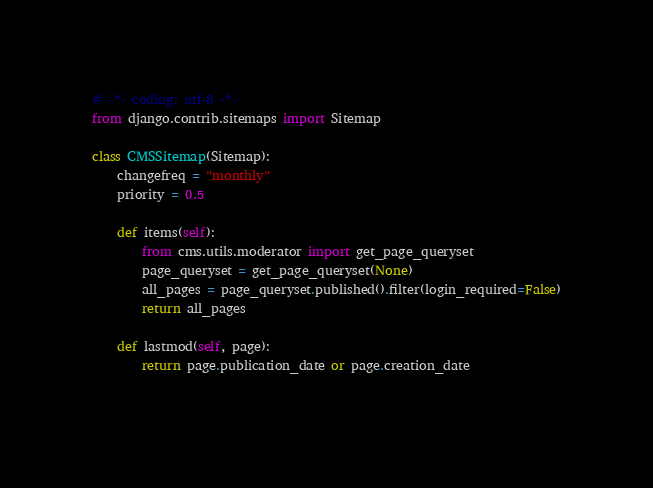<code> <loc_0><loc_0><loc_500><loc_500><_Python_># -*- coding: utf-8 -*-
from django.contrib.sitemaps import Sitemap

class CMSSitemap(Sitemap):
    changefreq = "monthly"
    priority = 0.5

    def items(self):
        from cms.utils.moderator import get_page_queryset
        page_queryset = get_page_queryset(None)
        all_pages = page_queryset.published().filter(login_required=False)
        return all_pages

    def lastmod(self, page):
        return page.publication_date or page.creation_date
    
</code> 